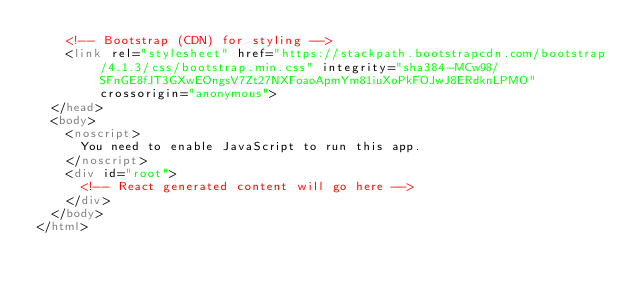Convert code to text. <code><loc_0><loc_0><loc_500><loc_500><_HTML_>    <!-- Bootstrap (CDN) for styling -->
    <link rel="stylesheet" href="https://stackpath.bootstrapcdn.com/bootstrap/4.1.3/css/bootstrap.min.css" integrity="sha384-MCw98/SFnGE8fJT3GXwEOngsV7Zt27NXFoaoApmYm81iuXoPkFOJwJ8ERdknLPMO" crossorigin="anonymous">
  </head>
  <body>
    <noscript>
      You need to enable JavaScript to run this app.
    </noscript>
    <div id="root">
      <!-- React generated content will go here -->
    </div>
  </body>
</html>
</code> 